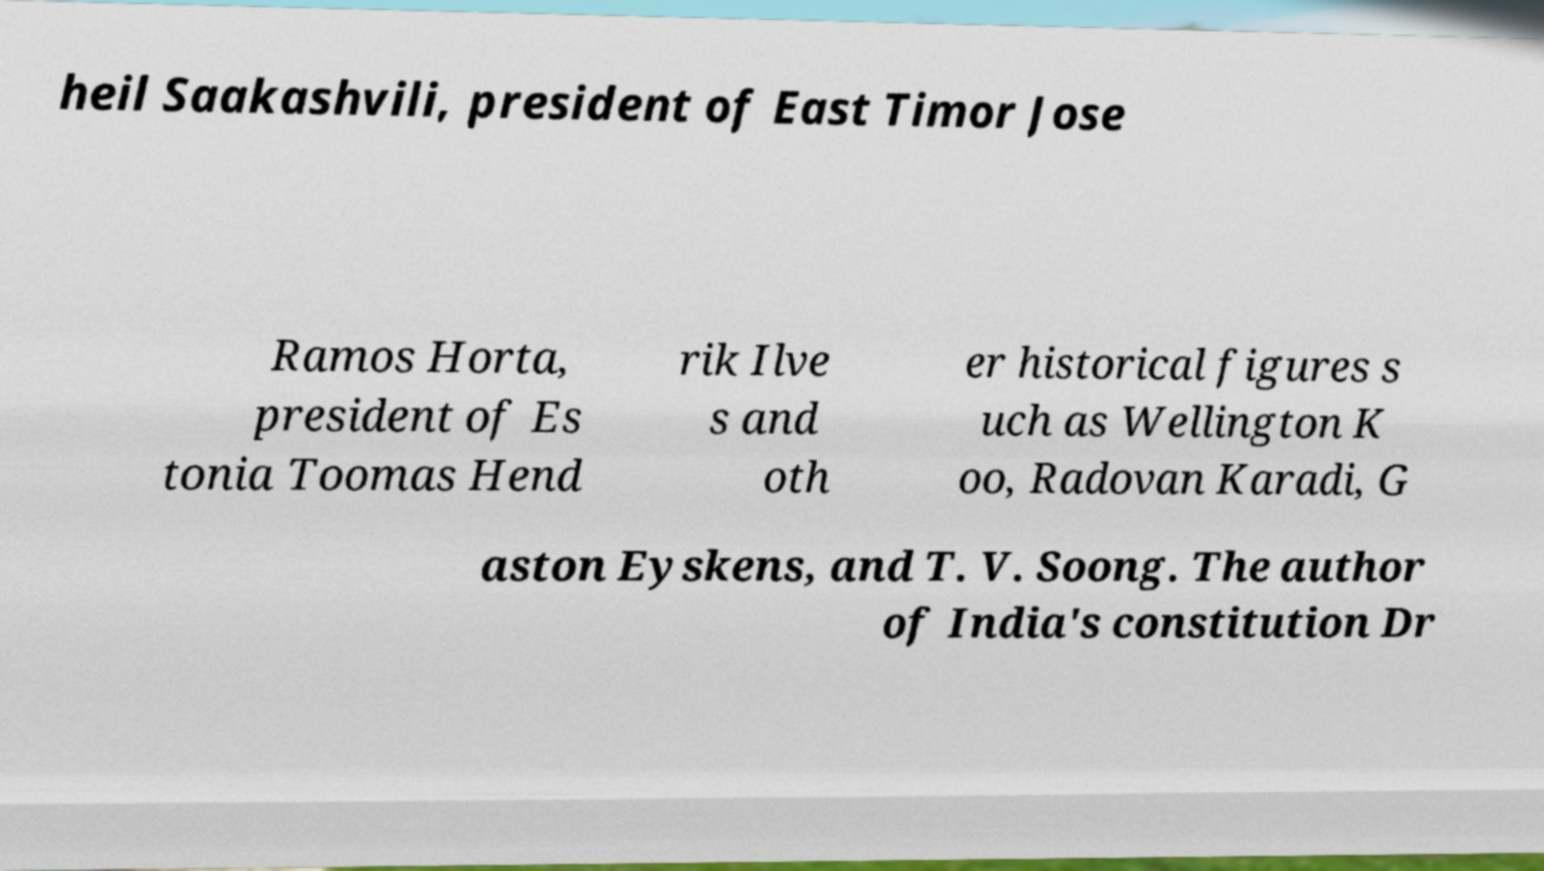Please identify and transcribe the text found in this image. heil Saakashvili, president of East Timor Jose Ramos Horta, president of Es tonia Toomas Hend rik Ilve s and oth er historical figures s uch as Wellington K oo, Radovan Karadi, G aston Eyskens, and T. V. Soong. The author of India's constitution Dr 